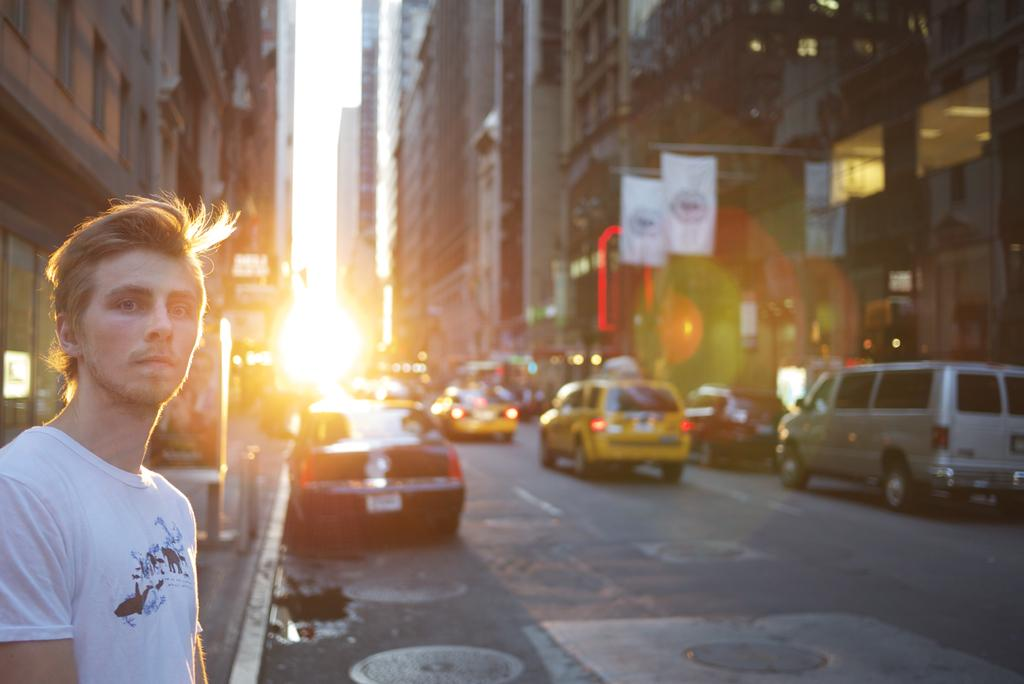What is the position of the man in the image? The man is standing on the left side of the image. What is the man wearing in the image? The man is wearing a white t-shirt. What can be seen moving in the image? There are vehicles moving in the image. What type of structures are present on either side of the road in the image? There are big buildings on either side of the road in the image. What type of songs can be heard coming from the pot in the image? There is no pot or songs present in the image. How many nuts are visible on the man's head in the image? There are no nuts visible on the man's head in the image. 